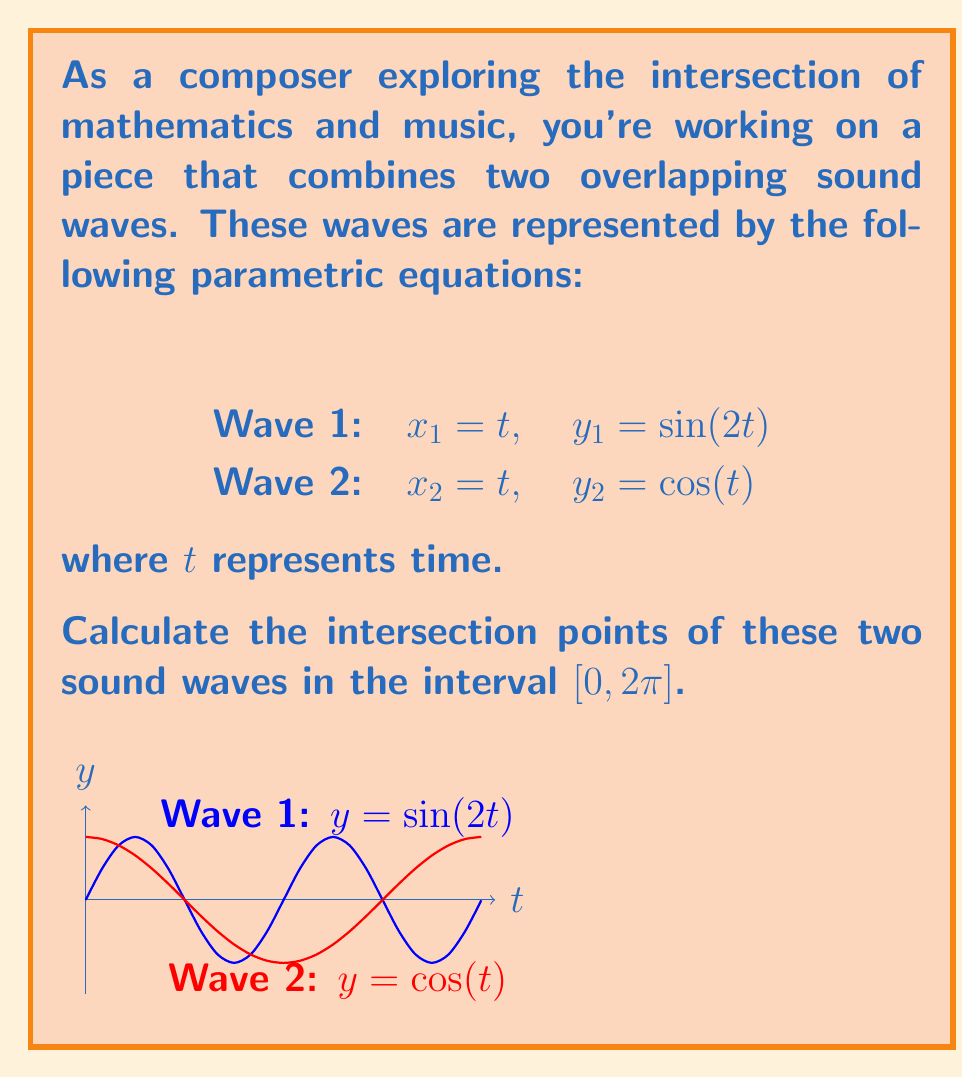Provide a solution to this math problem. Let's approach this step-by-step:

1) The intersection points occur when both $x$ and $y$ coordinates are equal for both waves. Since $x_1 = x_2 = t$ for both waves, we only need to solve the equation:

   $$\sin(2t) = \cos(t)$$

2) This is a transcendental equation that cannot be solved algebraically. We need to use numerical methods or graphical analysis.

3) However, we can simplify it using the double angle formula for cosine:

   $$\cos(2t) = 2\cos^2(t) - 1$$

4) Substituting $\sin(2t) = \sqrt{1 - \cos^2(2t)}$, we get:

   $$\sqrt{1 - (2\cos^2(t) - 1)^2} = \cos(t)$$

5) Squaring both sides:

   $$1 - (2\cos^2(t) - 1)^2 = \cos^2(t)$$

6) Expanding:

   $$1 - (4\cos^4(t) - 4\cos^2(t) + 1) = \cos^2(t)$$

7) Simplifying:

   $$4\cos^4(t) - 5\cos^2(t) + 1 = 0$$

8) This is a quadratic equation in $\cos^2(t)$. Let $u = \cos^2(t)$:

   $$4u^2 - 5u + 1 = 0$$

9) Solving this quadratic equation:

   $$u = \frac{5 \pm \sqrt{25 - 16}}{8} = \frac{5 \pm 3}{8}$$

10) The solutions are $u_1 = 1$ and $u_2 = \frac{1}{4}$

11) For $u_1 = 1$, $\cos(t) = \pm 1$, which occurs at $t = 0$ and $t = \pi$ in $[0, 2\pi]$

12) For $u_2 = \frac{1}{4}$, $\cos(t) = \pm \frac{1}{2}$, which occurs at $t = \frac{\pi}{3}$ and $t = \frac{5\pi}{3}$ in $[0, 2\pi]$

Therefore, the intersection points occur at $t = 0, \frac{\pi}{3}, \pi,$ and $\frac{5\pi}{3}$.
Answer: $(0,1)$, $(\frac{\pi}{3},\frac{1}{2})$, $(\pi,-1)$, $(\frac{5\pi}{3},-\frac{1}{2})$ 